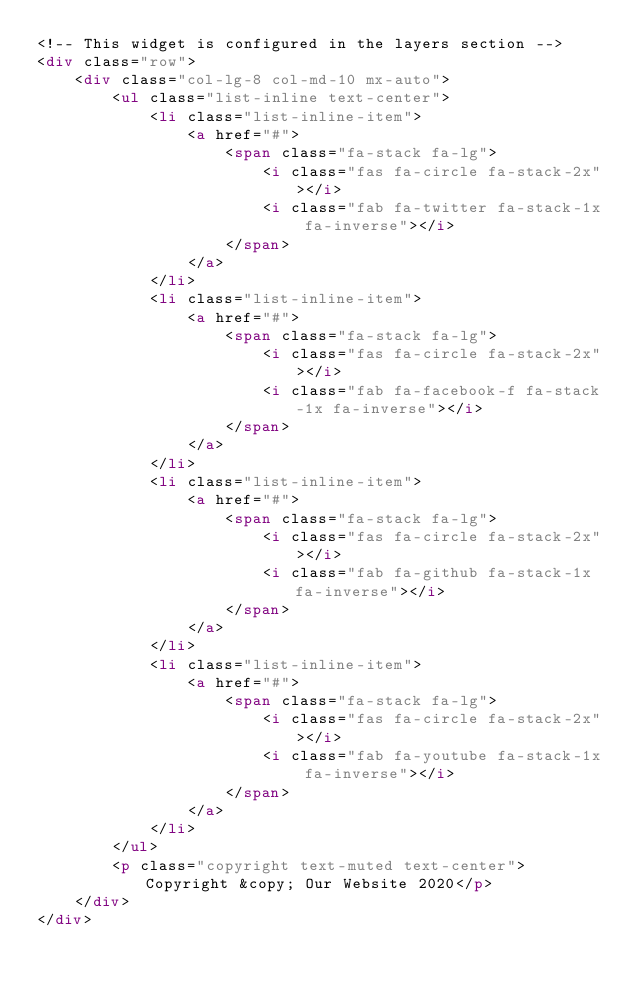Convert code to text. <code><loc_0><loc_0><loc_500><loc_500><_HTML_><!-- This widget is configured in the layers section -->
<div class="row">
    <div class="col-lg-8 col-md-10 mx-auto">
        <ul class="list-inline text-center">
            <li class="list-inline-item">
                <a href="#">
                    <span class="fa-stack fa-lg">
                        <i class="fas fa-circle fa-stack-2x"></i>
                        <i class="fab fa-twitter fa-stack-1x fa-inverse"></i>
                    </span>
                </a>
            </li>
            <li class="list-inline-item">
                <a href="#">
                    <span class="fa-stack fa-lg">
                        <i class="fas fa-circle fa-stack-2x"></i>
                        <i class="fab fa-facebook-f fa-stack-1x fa-inverse"></i>
                    </span>
                </a>
            </li>
            <li class="list-inline-item">
                <a href="#">
                    <span class="fa-stack fa-lg">
                        <i class="fas fa-circle fa-stack-2x"></i>
                        <i class="fab fa-github fa-stack-1x fa-inverse"></i>
                    </span>
                </a>
            </li>
            <li class="list-inline-item">
                <a href="#">
                    <span class="fa-stack fa-lg">
                        <i class="fas fa-circle fa-stack-2x"></i>
                        <i class="fab fa-youtube fa-stack-1x fa-inverse"></i>
                    </span>
                </a>
            </li>
        </ul>
        <p class="copyright text-muted text-center">Copyright &copy; Our Website 2020</p>
    </div>
</div></code> 